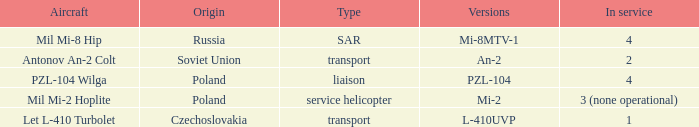Parse the full table. {'header': ['Aircraft', 'Origin', 'Type', 'Versions', 'In service'], 'rows': [['Mil Mi-8 Hip', 'Russia', 'SAR', 'Mi-8MTV-1', '4'], ['Antonov An-2 Colt', 'Soviet Union', 'transport', 'An-2', '2'], ['PZL-104 Wilga', 'Poland', 'liaison', 'PZL-104', '4'], ['Mil Mi-2 Hoplite', 'Poland', 'service helicopter', 'Mi-2', '3 (none operational)'], ['Let L-410 Turbolet', 'Czechoslovakia', 'transport', 'L-410UVP', '1']]} Tell me the origin for mi-2 Poland. 